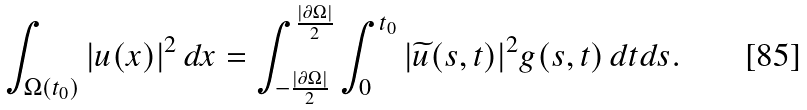Convert formula to latex. <formula><loc_0><loc_0><loc_500><loc_500>\int _ { \Omega ( t _ { 0 } ) } | u ( x ) | ^ { 2 } \, d x = \int _ { - \frac { | \partial \Omega | } 2 } ^ { \frac { | \partial \Omega | } 2 } \int _ { 0 } ^ { t _ { 0 } } | \widetilde { u } ( s , t ) | ^ { 2 } g ( s , t ) \, d t d s .</formula> 